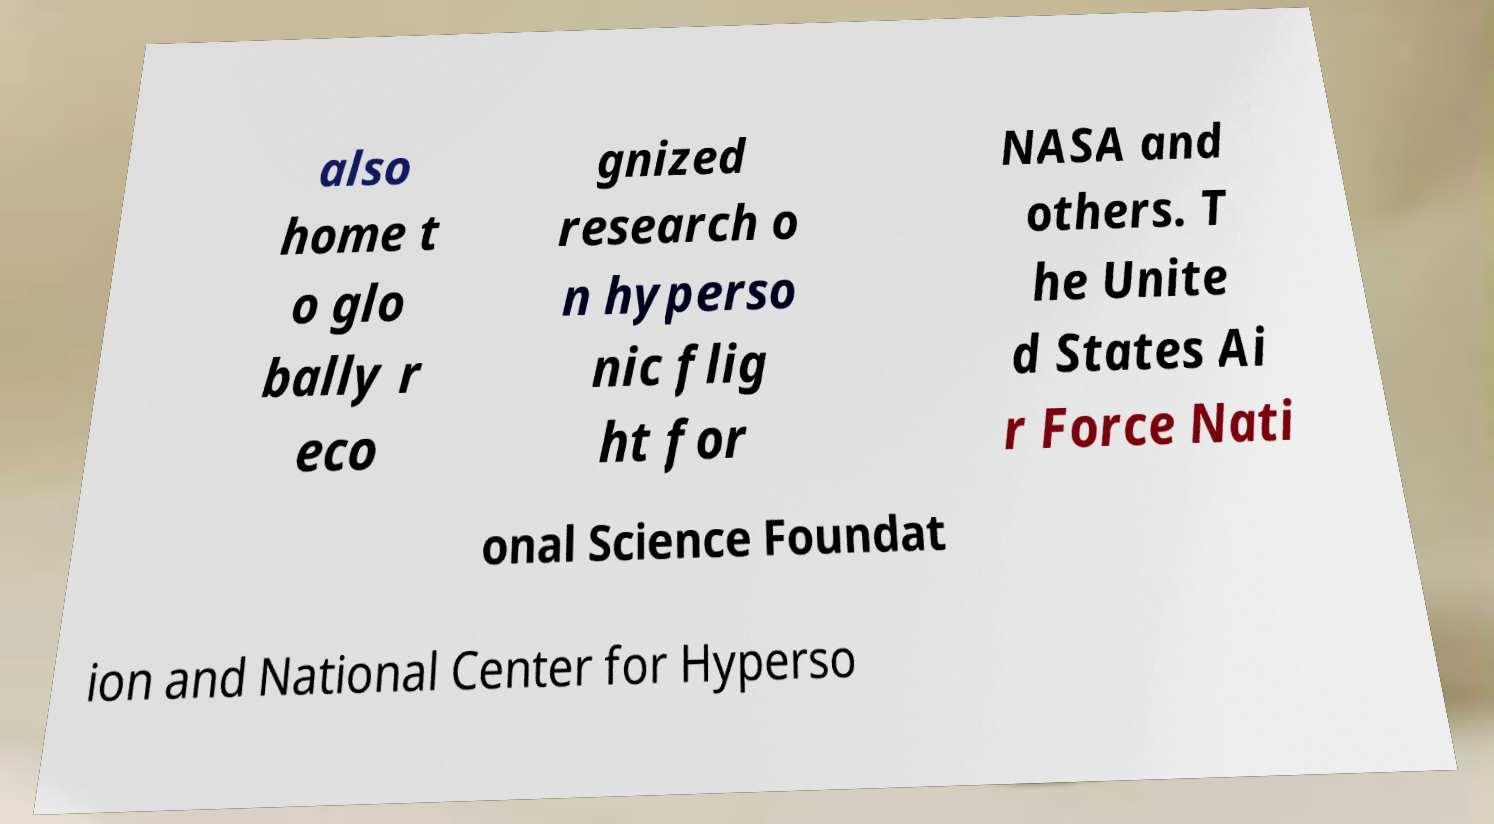I need the written content from this picture converted into text. Can you do that? also home t o glo bally r eco gnized research o n hyperso nic flig ht for NASA and others. T he Unite d States Ai r Force Nati onal Science Foundat ion and National Center for Hyperso 